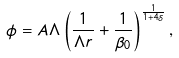Convert formula to latex. <formula><loc_0><loc_0><loc_500><loc_500>\phi = A \Lambda \left ( \frac { 1 } { \Lambda r } + \frac { 1 } { \beta _ { 0 } } \right ) ^ { \frac { 1 } { 1 + 4 \delta } } ,</formula> 